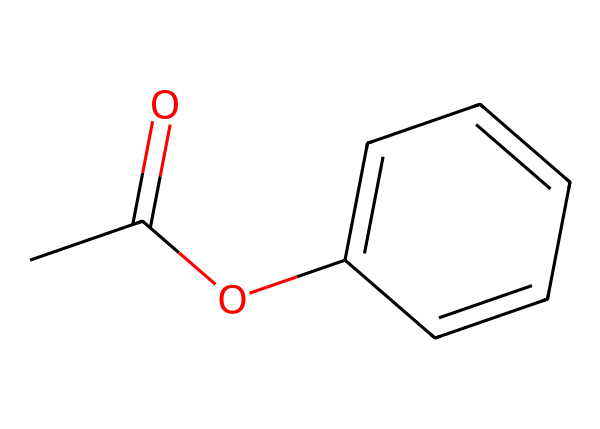What is the functional group present in this compound? The given SMILES indicates the presence of an ester functional group, as evidenced by the 'CC(=O)O' segment at the beginning of the structure, which shows a carbonyl (C=O) bonded to an oxygen atom (O).
Answer: ester How many carbon atoms are in the structure? By analyzing the SMILES notation, the structure consists of 9 carbon atoms in total: 2 from the -C(=O)O part and 7 from the aromatic ring.
Answer: 9 What is the type of aromatic compound represented here? The presence of a benzene ring (C1=CC=CC=C1) within the structure indicates that this compound is a mono-aromatic compound, specifically an aromatic ester.
Answer: aromatic ester What is the total number of hydrogen atoms in this structure? The structure contains a total of 8 hydrogen atoms. This can be deduced by counting the hydrogen atoms on the methyl group (3), the hydrogen atoms on the aromatic ring (4), and the hydrogen bonded to the carbon adjacent to the ester functional group (1).
Answer: 8 Does this chemical likely have a sweet or fruity scent? Aromatic esters like this one often have fruity fragrances, as many natural fruit aromas are esters—thus making this compound likely to impart a sweet or fruity scent, typical in air fresheners.
Answer: fruity What type of reactions can this compound undergo? Aromatic esters can undergo hydrolysis, transesterification, and nucleophilic acyl substitution reactions. Thus, it has multiple reactivity patterns due to its functional groups.
Answer: hydrolysis What is the significance of the aromatic ring in air fresheners? The aromatic ring is significant as it provides stability and contributes to the fragrance profile, allowing for long-lasting scents in air fresheners. This stability also affects the volatility and release of the fragrance when used.
Answer: stability 